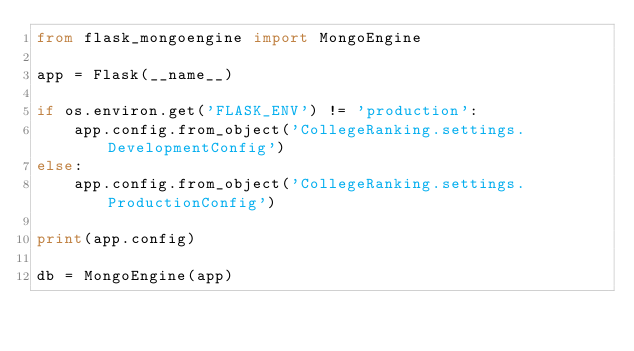Convert code to text. <code><loc_0><loc_0><loc_500><loc_500><_Python_>from flask_mongoengine import MongoEngine

app = Flask(__name__)

if os.environ.get('FLASK_ENV') != 'production':
    app.config.from_object('CollegeRanking.settings.DevelopmentConfig')
else:
    app.config.from_object('CollegeRanking.settings.ProductionConfig')

print(app.config)

db = MongoEngine(app)</code> 